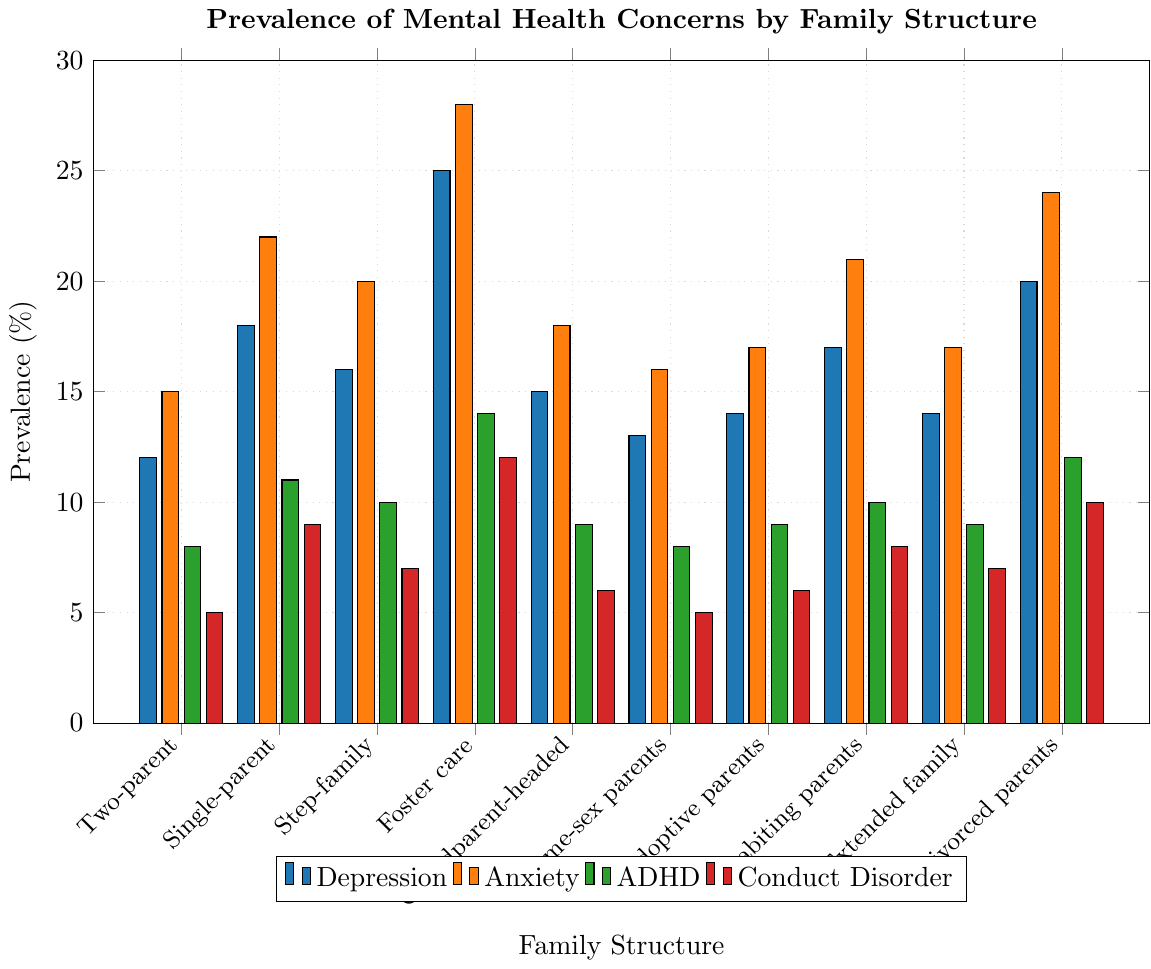What's the highest prevalence of Anxiety among the family structures? The highest value under the Anxiety category is 28%. This value corresponds to the Foster care group which has the tallest bar in orange color representing the prevalence of Anxiety.
Answer: 28% Which family structure has the lowest prevalence of ADHD? The lowest value under the ADHD category is 8%, which is shared by Two-parent and Same-sex parents groups. These bars are the shortest in green color.
Answer: Two-parent, Same-sex parents Compare the prevalence of Conduct Disorder between Foster care and Divorced parents. Foster care has a 12% prevalence of Conduct Disorder, while Divorced parents have a 10% prevalence. This means Foster care has a higher prevalence by 2%.
Answer: Foster care What's the sum of the prevalence of Depression and Anxiety in the Single-parent family structure? The values for Depression and Anxiety in Single-parent are 18% and 22% respectively. Adding these values, 18 + 22 = 40.
Answer: 40% On average, what is the prevalence of Conduct Disorder across all family structures? The values for Conduct Disorder in all groups are 5, 9, 7, 12, 6, 5, 6, 8, 7, and 10. Summing these values gives 75. There are 10 family structures, so the average is 75/10 = 7.5%.
Answer: 7.5% Which family structure demonstrates a similar prevalence pattern for both Depression and ADHD? Both the Two-parent and Same-sex parents family structures show this pattern, having 12% and 8% for Two-parent and 13% and 8% for Same-sex parents, respectively.
Answer: Two-parent, Same-sex parents What is the difference in the prevalence of Anxiety between Step-family and Cohabiting parents? The prevalence of Anxiety in Step-family is 20%, and in Cohabiting parents, it is 21%. The difference is 21 - 20 = 1%.
Answer: 1% List the family structures with a prevalence of Depression greater than 15%. Checking the Depression values, Single-parent (18%), Foster care (25%), Cohabiting parents (17%), and Divorced parents (20%) have values greater than 15%.
Answer: Single-parent, Foster care, Cohabiting parents, Divorced parents What is the median prevalence of Conduct Disorder for the listed family structures? Listing Conduct Disorder values in ascending order: 5, 5, 6, 6, 7, 7, 8, 9, 10, 12. The middle values for 10 data points are 7 and 7, so the median is (7 + 7) / 2 = 7%.
Answer: 7% Observe and compare the prevalence of Depression and Anxiety in the Divorced parents family structure. The Divorced parents have 20% for Depression and 24% for Anxiety. This shows that Anxiety is higher by 24 - 20 = 4%.
Answer: Anxiety (4%) 